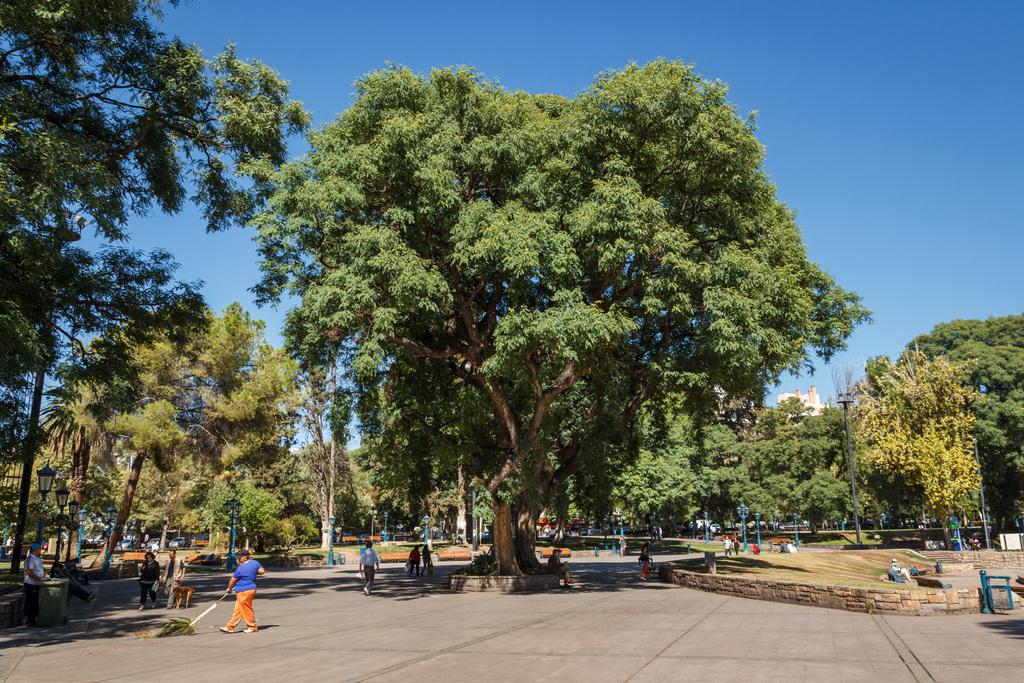What can be seen on the road in the image? There are persons on the road in the image. What type of vegetation is present on the ground? There are trees and grass on the ground in the image. What is visible in the background of the image? The background of the image includes a blue sky. What type of pencil can be seen in the image? There is no pencil present in the image. What vegetable is being used as a prop in the image? There is no vegetable present in the image. 